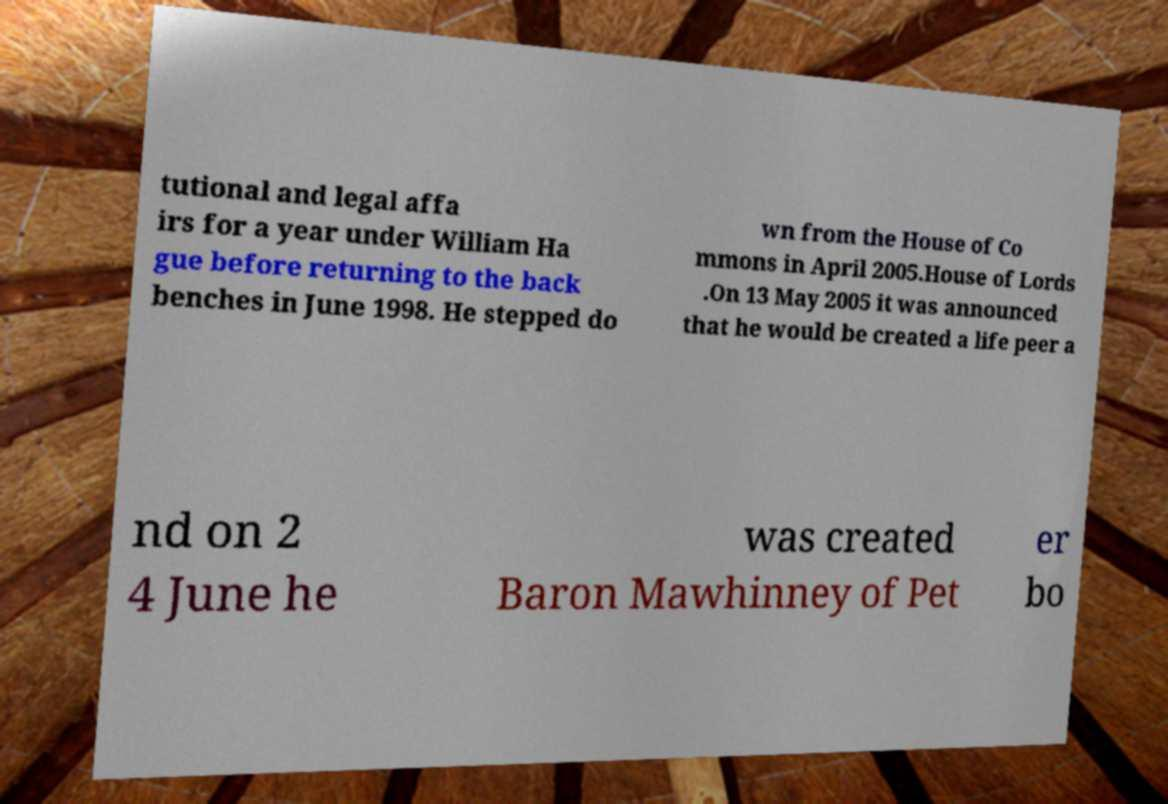Can you accurately transcribe the text from the provided image for me? tutional and legal affa irs for a year under William Ha gue before returning to the back benches in June 1998. He stepped do wn from the House of Co mmons in April 2005.House of Lords .On 13 May 2005 it was announced that he would be created a life peer a nd on 2 4 June he was created Baron Mawhinney of Pet er bo 